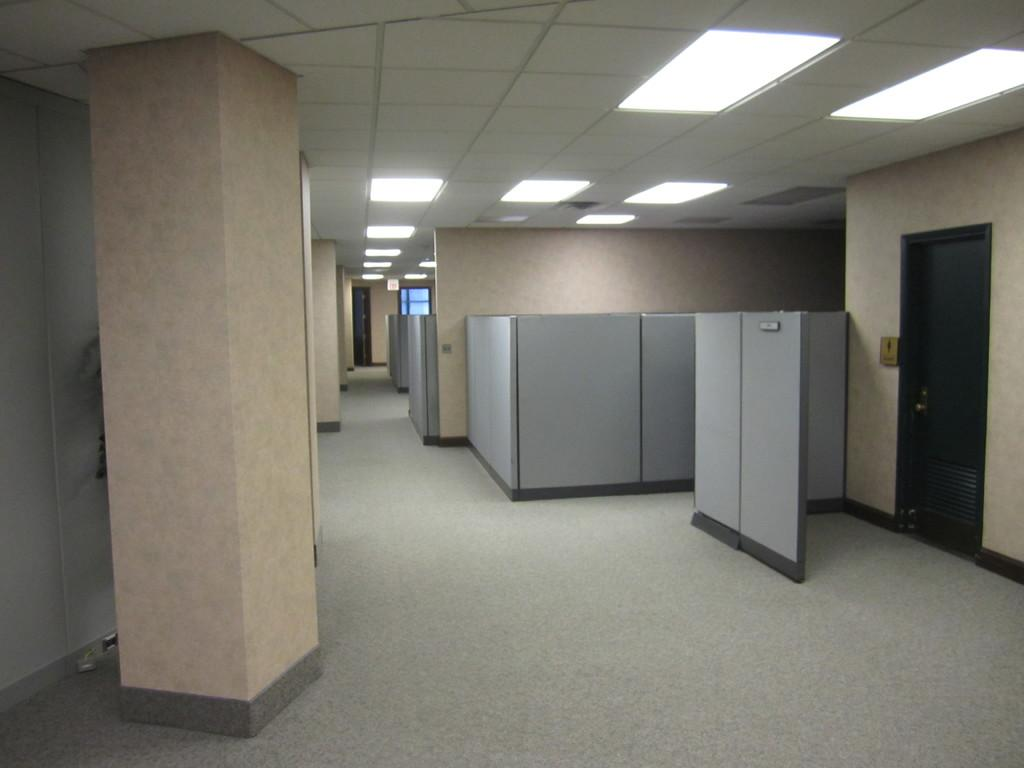What is located in the center of the image? There is a wall, a door, pillars, lights, and a few other objects in the center of the image. Can you describe the door in the image? The door is in the center of the image, and it is located within the wall. What type of objects are present alongside the wall, door, and pillars? There are lights and a few other objects in the center of the image. Can you see a fight happening in the image? There is no fight present in the image. What type of badge is visible on the wall in the image? There is no badge present in the image. 